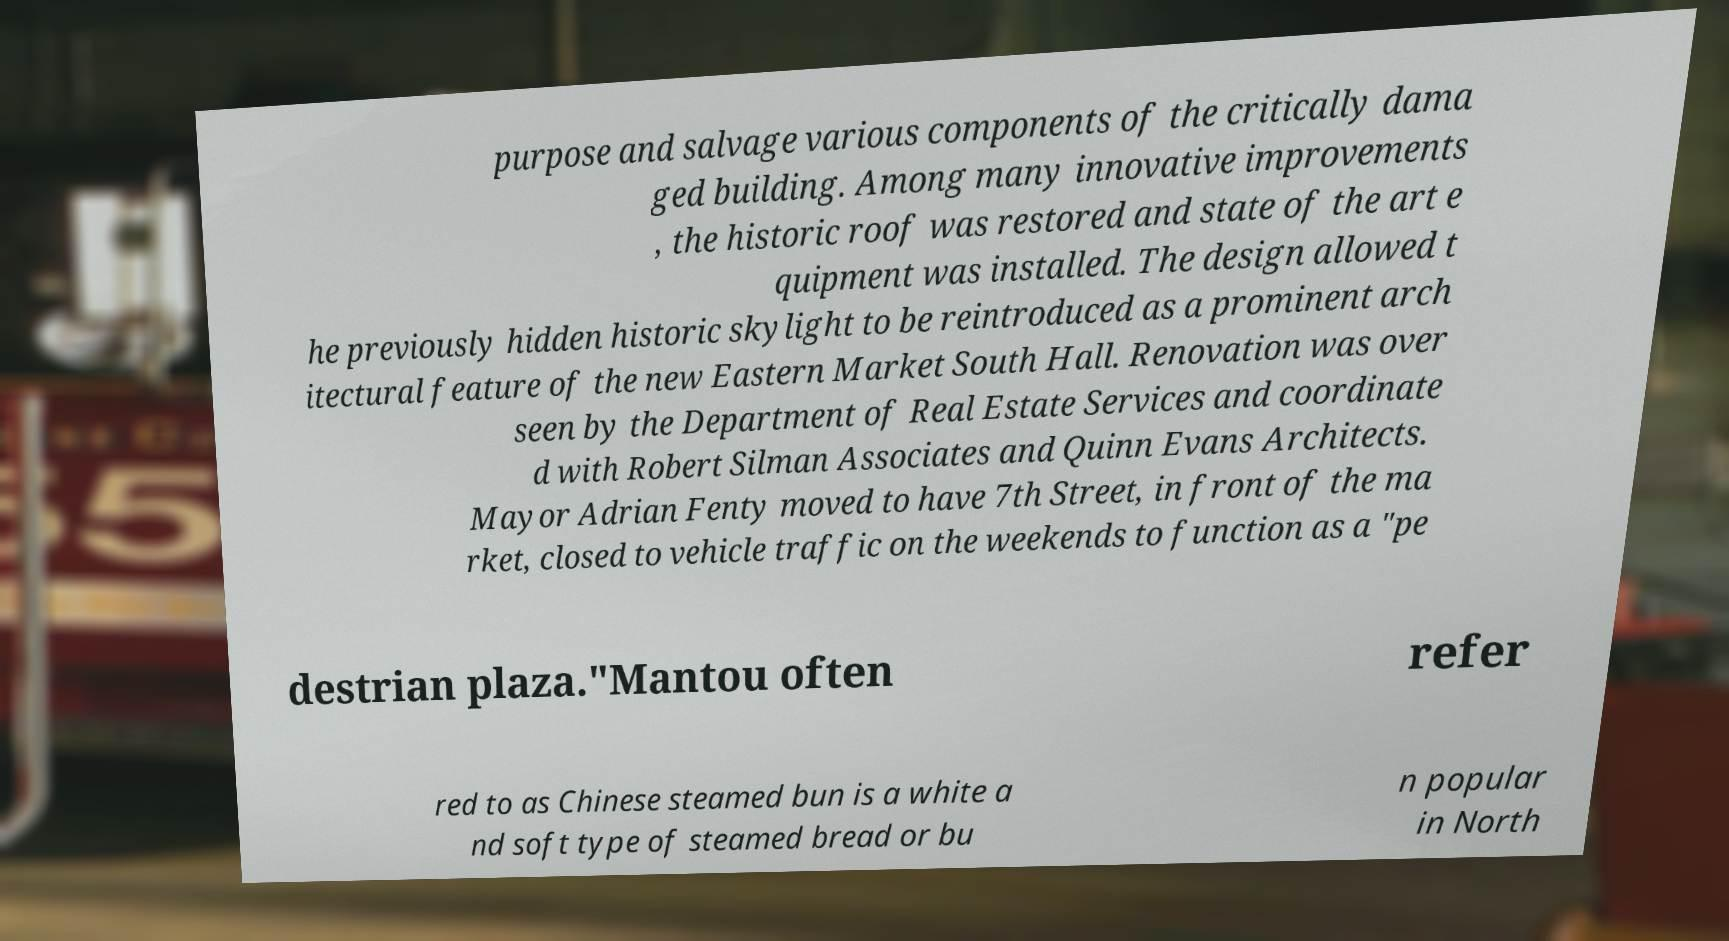I need the written content from this picture converted into text. Can you do that? purpose and salvage various components of the critically dama ged building. Among many innovative improvements , the historic roof was restored and state of the art e quipment was installed. The design allowed t he previously hidden historic skylight to be reintroduced as a prominent arch itectural feature of the new Eastern Market South Hall. Renovation was over seen by the Department of Real Estate Services and coordinate d with Robert Silman Associates and Quinn Evans Architects. Mayor Adrian Fenty moved to have 7th Street, in front of the ma rket, closed to vehicle traffic on the weekends to function as a "pe destrian plaza."Mantou often refer red to as Chinese steamed bun is a white a nd soft type of steamed bread or bu n popular in North 